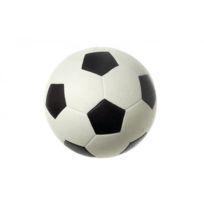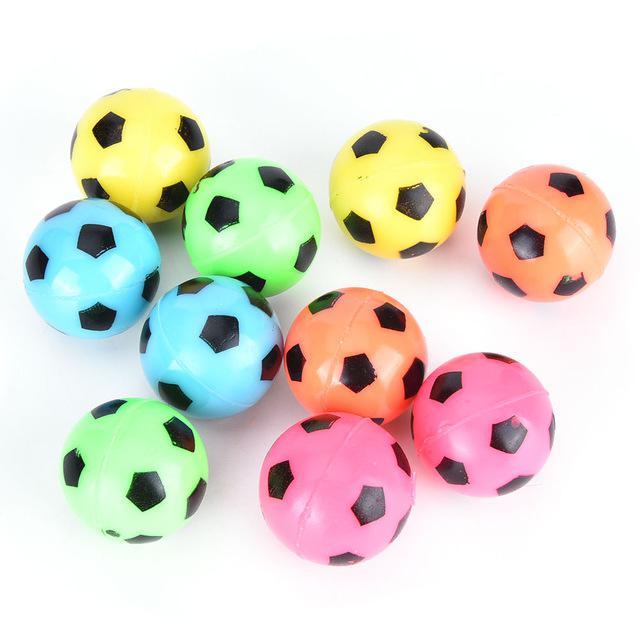The first image is the image on the left, the second image is the image on the right. Evaluate the accuracy of this statement regarding the images: "There are more than 3 balls painted like soccer balls, and there are no numbers on any of them.". Is it true? Answer yes or no. Yes. The first image is the image on the left, the second image is the image on the right. Evaluate the accuracy of this statement regarding the images: "Two of the soccer balls are pink.". Is it true? Answer yes or no. Yes. 